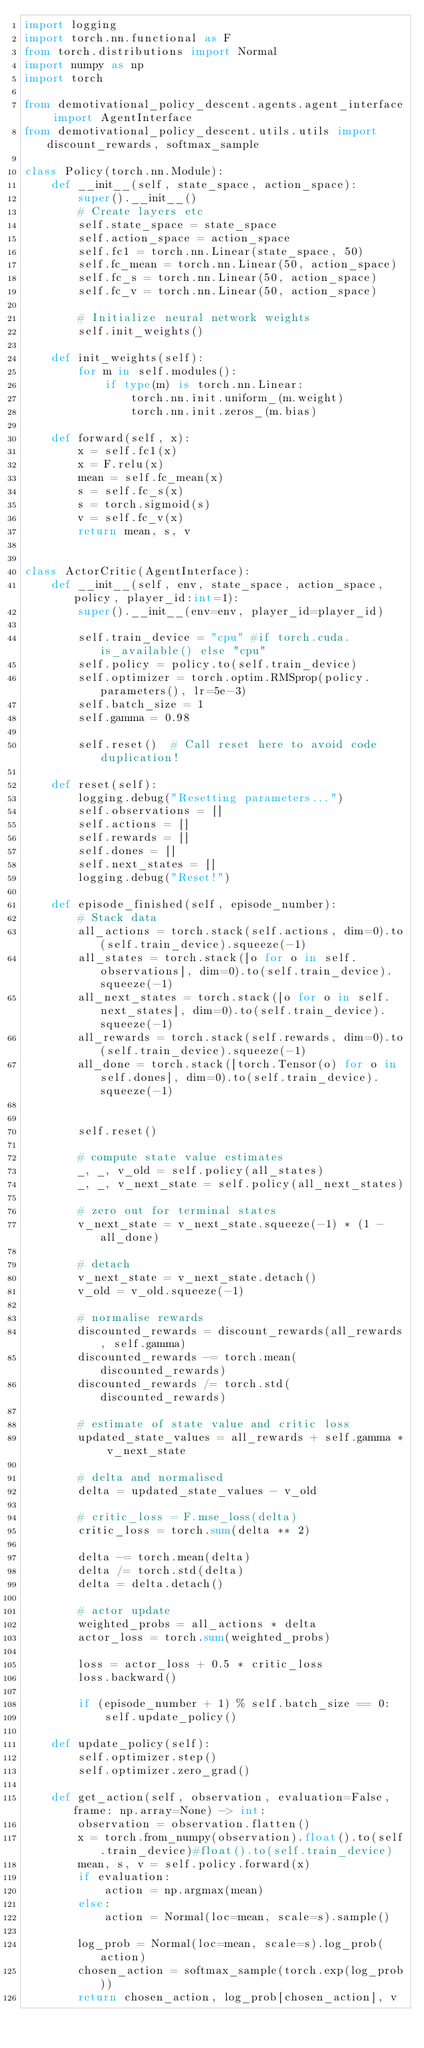Convert code to text. <code><loc_0><loc_0><loc_500><loc_500><_Python_>import logging
import torch.nn.functional as F
from torch.distributions import Normal
import numpy as np
import torch

from demotivational_policy_descent.agents.agent_interface import AgentInterface
from demotivational_policy_descent.utils.utils import discount_rewards, softmax_sample

class Policy(torch.nn.Module):
    def __init__(self, state_space, action_space):
        super().__init__()
        # Create layers etc
        self.state_space = state_space
        self.action_space = action_space
        self.fc1 = torch.nn.Linear(state_space, 50)
        self.fc_mean = torch.nn.Linear(50, action_space)
        self.fc_s = torch.nn.Linear(50, action_space)
        self.fc_v = torch.nn.Linear(50, action_space)

        # Initialize neural network weights
        self.init_weights()

    def init_weights(self):
        for m in self.modules():
            if type(m) is torch.nn.Linear:
                torch.nn.init.uniform_(m.weight)
                torch.nn.init.zeros_(m.bias)

    def forward(self, x):
        x = self.fc1(x)
        x = F.relu(x)
        mean = self.fc_mean(x)
        s = self.fc_s(x)
        s = torch.sigmoid(s)
        v = self.fc_v(x)
        return mean, s, v


class ActorCritic(AgentInterface):
    def __init__(self, env, state_space, action_space, policy, player_id:int=1):
        super().__init__(env=env, player_id=player_id)

        self.train_device = "cpu" #if torch.cuda.is_available() else "cpu"
        self.policy = policy.to(self.train_device)
        self.optimizer = torch.optim.RMSprop(policy.parameters(), lr=5e-3)
        self.batch_size = 1
        self.gamma = 0.98

        self.reset()  # Call reset here to avoid code duplication!

    def reset(self):
        logging.debug("Resetting parameters...")
        self.observations = []
        self.actions = []
        self.rewards = []
        self.dones = []
        self.next_states = []
        logging.debug("Reset!")

    def episode_finished(self, episode_number):
        # Stack data
        all_actions = torch.stack(self.actions, dim=0).to(self.train_device).squeeze(-1)
        all_states = torch.stack([o for o in self.observations], dim=0).to(self.train_device).squeeze(-1)
        all_next_states = torch.stack([o for o in self.next_states], dim=0).to(self.train_device).squeeze(-1)
        all_rewards = torch.stack(self.rewards, dim=0).to(self.train_device).squeeze(-1)
        all_done = torch.stack([torch.Tensor(o) for o in self.dones], dim=0).to(self.train_device).squeeze(-1)


        self.reset()

        # compute state value estimates
        _, _, v_old = self.policy(all_states)
        _, _, v_next_state = self.policy(all_next_states)

        # zero out for terminal states
        v_next_state = v_next_state.squeeze(-1) * (1 - all_done)

        # detach
        v_next_state = v_next_state.detach()
        v_old = v_old.squeeze(-1)

        # normalise rewards
        discounted_rewards = discount_rewards(all_rewards, self.gamma)
        discounted_rewards -= torch.mean(discounted_rewards)
        discounted_rewards /= torch.std(discounted_rewards)

        # estimate of state value and critic loss
        updated_state_values = all_rewards + self.gamma * v_next_state

        # delta and normalised
        delta = updated_state_values - v_old

        # critic_loss = F.mse_loss(delta)
        critic_loss = torch.sum(delta ** 2)

        delta -= torch.mean(delta)
        delta /= torch.std(delta)
        delta = delta.detach()

        # actor update
        weighted_probs = all_actions * delta
        actor_loss = torch.sum(weighted_probs)

        loss = actor_loss + 0.5 * critic_loss
        loss.backward()

        if (episode_number + 1) % self.batch_size == 0:
            self.update_policy()

    def update_policy(self):
        self.optimizer.step()
        self.optimizer.zero_grad()

    def get_action(self, observation, evaluation=False, frame: np.array=None) -> int:
        observation = observation.flatten()
        x = torch.from_numpy(observation).float().to(self.train_device)#float().to(self.train_device)
        mean, s, v = self.policy.forward(x)
        if evaluation:
            action = np.argmax(mean)
        else:
            action = Normal(loc=mean, scale=s).sample()

        log_prob = Normal(loc=mean, scale=s).log_prob(action)
        chosen_action = softmax_sample(torch.exp(log_prob))
        return chosen_action, log_prob[chosen_action], v
</code> 